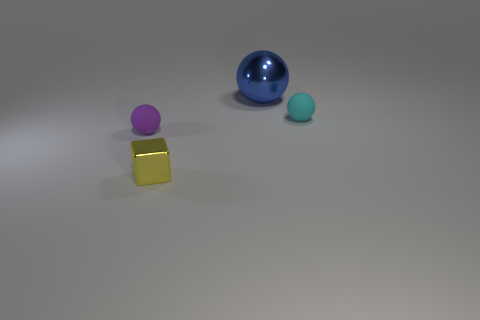Add 3 blue objects. How many objects exist? 7 Subtract all matte spheres. How many spheres are left? 1 Subtract all red cubes. Subtract all yellow cylinders. How many cubes are left? 1 Subtract all gray cylinders. How many cyan balls are left? 1 Subtract all cyan objects. Subtract all blue metallic balls. How many objects are left? 2 Add 1 small yellow objects. How many small yellow objects are left? 2 Add 4 blue metallic cylinders. How many blue metallic cylinders exist? 4 Subtract 0 gray cylinders. How many objects are left? 4 Subtract all spheres. How many objects are left? 1 